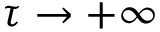<formula> <loc_0><loc_0><loc_500><loc_500>\tau \to + \infty</formula> 